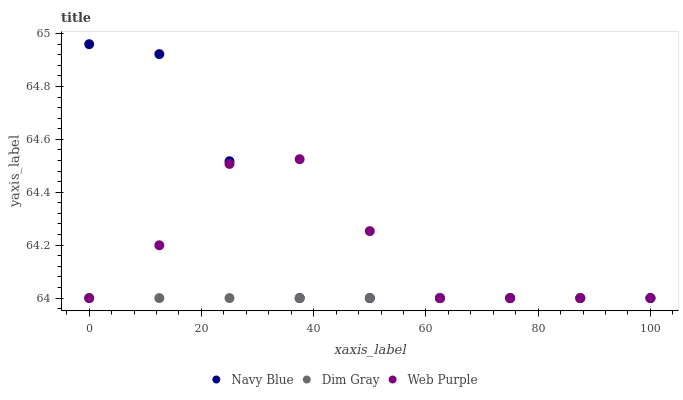Does Dim Gray have the minimum area under the curve?
Answer yes or no. Yes. Does Navy Blue have the maximum area under the curve?
Answer yes or no. Yes. Does Web Purple have the minimum area under the curve?
Answer yes or no. No. Does Web Purple have the maximum area under the curve?
Answer yes or no. No. Is Dim Gray the smoothest?
Answer yes or no. Yes. Is Navy Blue the roughest?
Answer yes or no. Yes. Is Web Purple the smoothest?
Answer yes or no. No. Is Web Purple the roughest?
Answer yes or no. No. Does Navy Blue have the lowest value?
Answer yes or no. Yes. Does Navy Blue have the highest value?
Answer yes or no. Yes. Does Web Purple have the highest value?
Answer yes or no. No. Does Web Purple intersect Dim Gray?
Answer yes or no. Yes. Is Web Purple less than Dim Gray?
Answer yes or no. No. Is Web Purple greater than Dim Gray?
Answer yes or no. No. 